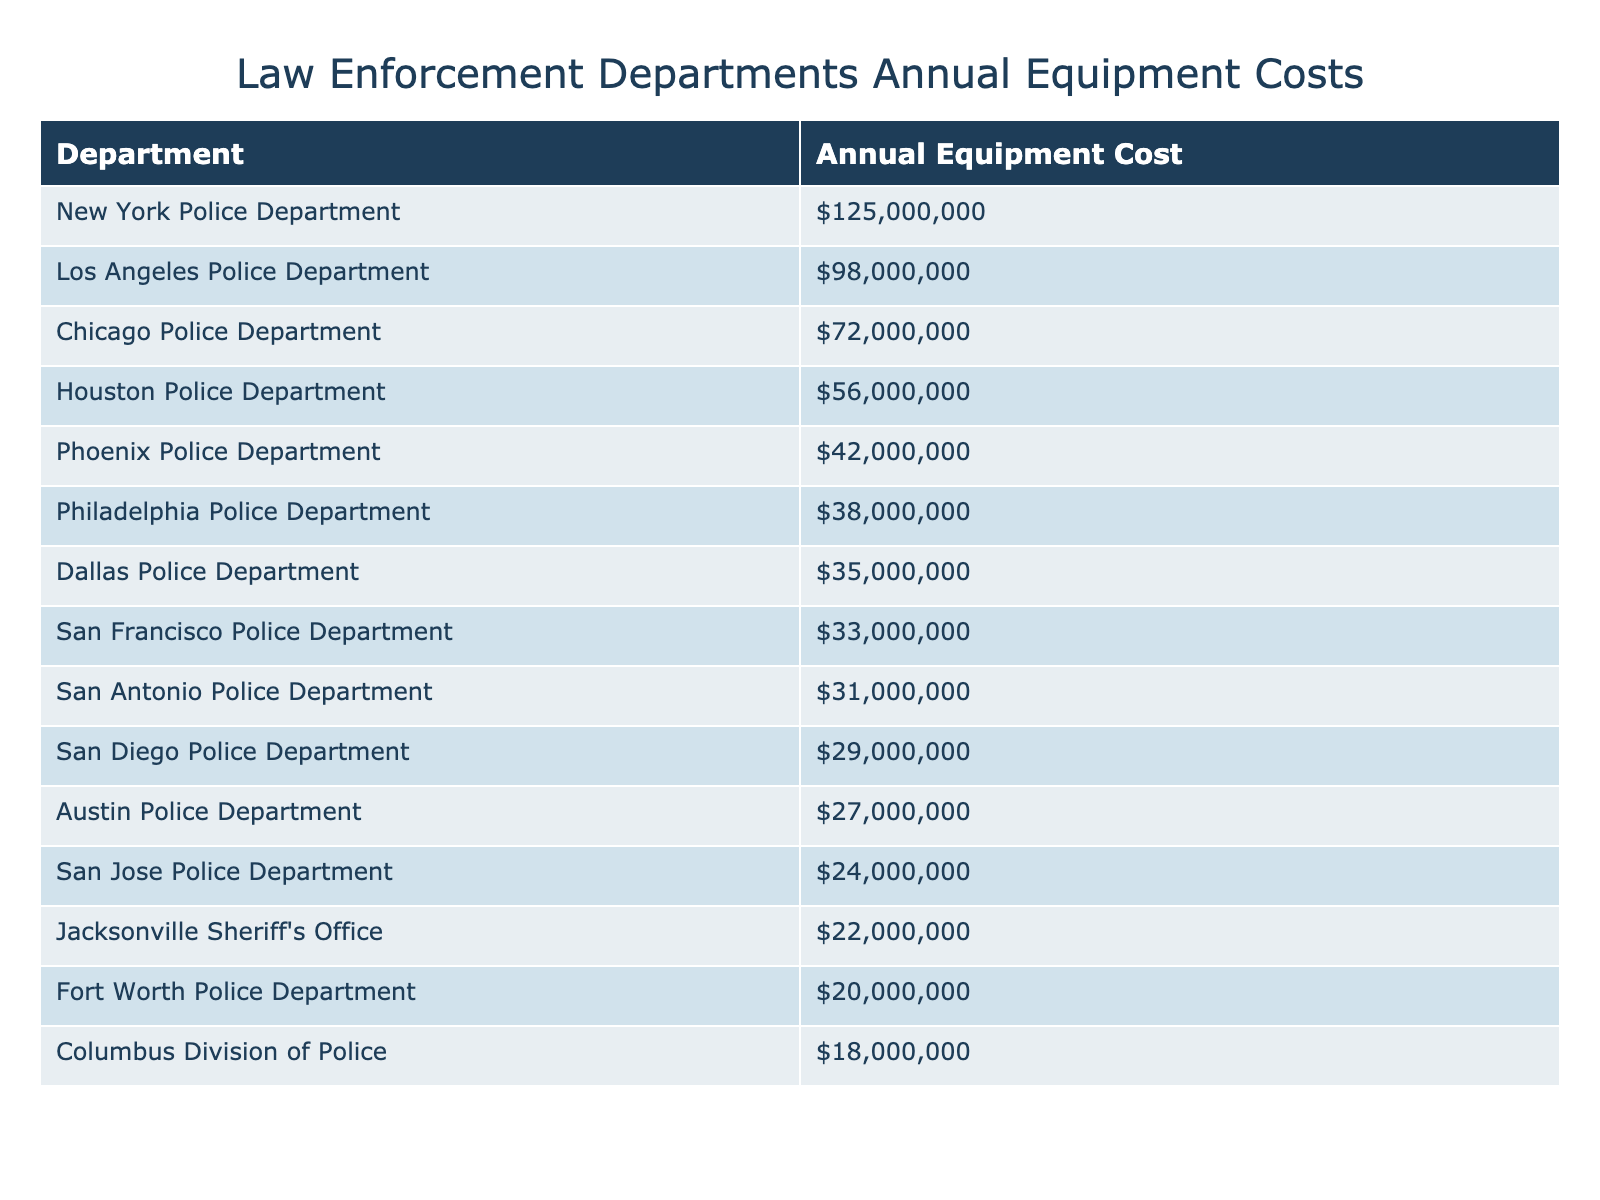What is the annual equipment cost for the New York Police Department? The table shows that the New York Police Department has an annual equipment cost listed as $125,000,000.
Answer: $125,000,000 Which department has the highest annual equipment cost? By looking at the sorted list in the table, the department with the highest annual equipment cost is the New York Police Department with $125,000,000.
Answer: New York Police Department What is the annual equipment cost of the San Diego Police Department? The table indicates that the San Diego Police Department's annual equipment cost is $29,000,000.
Answer: $29,000,000 What is the total annual equipment cost of the top three departments? The top three departments and their costs are: New York Police Department ($125,000,000), Los Angeles Police Department ($98,000,000), and Chicago Police Department ($72,000,000). Adding those gives $125,000,000 + $98,000,000 + $72,000,000 = $295,000,000.
Answer: $295,000,000 Is the equipment cost for the Houston Police Department greater than or equal to that of the Philadelphia Police Department? The table shows Houston Police Department's cost as $56,000,000 and Philadelphia Police Department's cost as $38,000,000. Since $56,000,000 is greater than $38,000,000, the statement is true.
Answer: True What is the average annual equipment cost of the bottom five departments? The bottom five departments and their costs are: San Jose Police Department ($24,000,000), Austin Police Department ($27,000,000), Jacksonville Sheriff's Office ($22,000,000), Fort Worth Police Department ($20,000,000), and Columbus Division of Police ($18,000,000). The sum is $24,000,000 + $27,000,000 + $22,000,000 + $20,000,000 + $18,000,000 = $111,000,000. Dividing by 5 gives an average of $111,000,000 / 5 = $22,200,000.
Answer: $22,200,000 What is the difference in annual equipment costs between the Chicago Police Department and the San Antonio Police Department? The annual cost for Chicago Police Department is $72,000,000 and for San Antonio Police Department is $31,000,000. The difference is $72,000,000 - $31,000,000 = $41,000,000.
Answer: $41,000,000 Which department spends less than $30,000,000 on annual equipment costs? By reviewing the table, the departments that spend less than $30,000,000 are the San Jose Police Department, Austin Police Department, Jacksonville Sheriff's Office, Fort Worth Police Department, and Columbus Division of Police.
Answer: Five departments What is the total annual equipment cost for departments located in Texas? The Texas departments and their costs are: Houston Police Department ($56,000,000), San Antonio Police Department ($31,000,000), Dallas Police Department ($35,000,000), and Fort Worth Police Department ($20,000,000). Adding these gives $56,000,000 + $31,000,000 + $35,000,000 + $20,000,000 = $142,000,000.
Answer: $142,000,000 Are there more departments with an annual equipment cost above or below $50,000,000? There are six departments with costs above $50,000,000: New York, Los Angeles, Chicago, Houston, and San Antonio. There are nine departments below $50,000,000. Since 9 is greater than 6, the answer is that there are more below $50,000,000.
Answer: Below $50,000,000 is more 